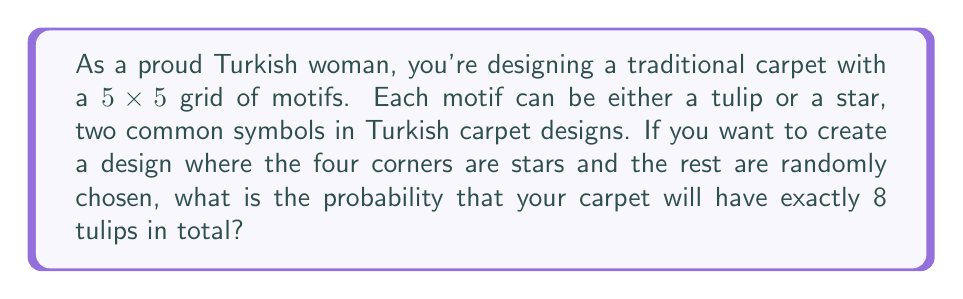Show me your answer to this math problem. Let's approach this step-by-step:

1) First, we need to understand the given information:
   - The carpet has a 5x5 grid, so 25 motifs in total.
   - The four corners must be stars.
   - We want exactly 8 tulips in the remaining 21 spaces.

2) This is a combination problem. We need to choose 8 spaces out of 21 to place the tulips.

3) The number of ways to choose 8 items from 21 is given by the combination formula:

   $${21 \choose 8} = \frac{21!}{8!(21-8)!} = \frac{21!}{8!13!}$$

4) Let's calculate this:
   
   $${21 \choose 8} = 293,930$$

5) Now, for each of these combinations, the remaining 13 spaces (plus the 4 corners) will be stars.

6) The total number of possible designs (with stars in the corners) is $2^{21}$, because for each of the 21 non-corner spaces, we have 2 choices.

7) Therefore, the probability is:

   $$P(\text{exactly 8 tulips}) = \frac{{21 \choose 8}}{2^{21}}$$

8) Let's calculate this:

   $$P(\text{exactly 8 tulips}) = \frac{293,930}{2,097,152} \approx 0.1402$$
Answer: The probability of having exactly 8 tulips in the carpet design is $\frac{293,930}{2,097,152}$ or approximately 0.1402 (14.02%). 